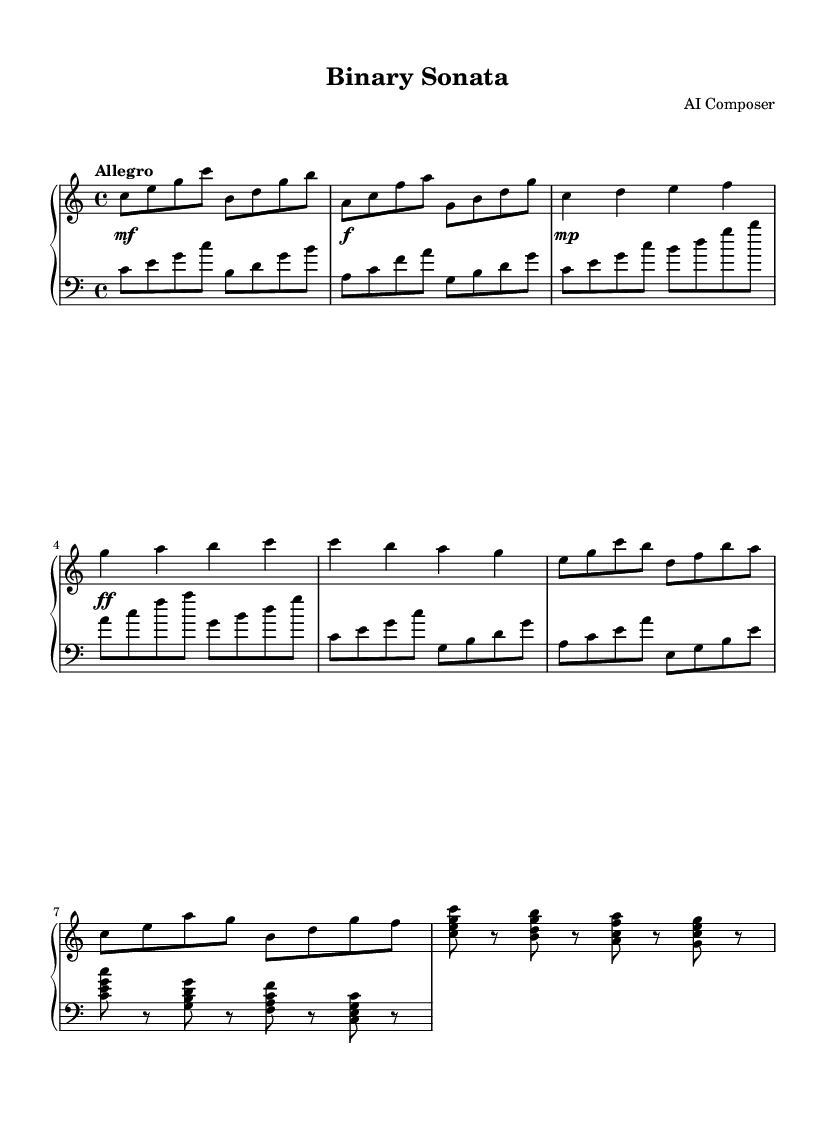What is the key signature of this music? The key signature is C major, which has no sharps or flats as indicated at the beginning of the score.
Answer: C major What is the time signature of this music? The time signature is 4/4, which means there are four beats in a measure. This is indicated at the beginning of the score.
Answer: 4/4 What is the tempo marking of this piece? The tempo marking is "Allegro," which indicates a fast and lively pace. This is noted at the start of the piece.
Answer: Allegro How many measures are in the introduction? The introduction contains 5 measures, counting the measures in the right hand and left hand.
Answer: 5 What is the dynamics marking at the beginning of the score? The dynamics markings indicate a moderate volume starting at mezzo-forte, then progressing to forte. This shows the dynamics in the piece.
Answer: mezzo-forte Which section follows Theme A? Theme B follows Theme A, as the score shows a transition from Theme A to Theme B after the first appearance of the themes.
Answer: Theme B What is the final section of the piece called? The final section of the piece is called the Coda, which is marked at the end of the score.
Answer: Coda 